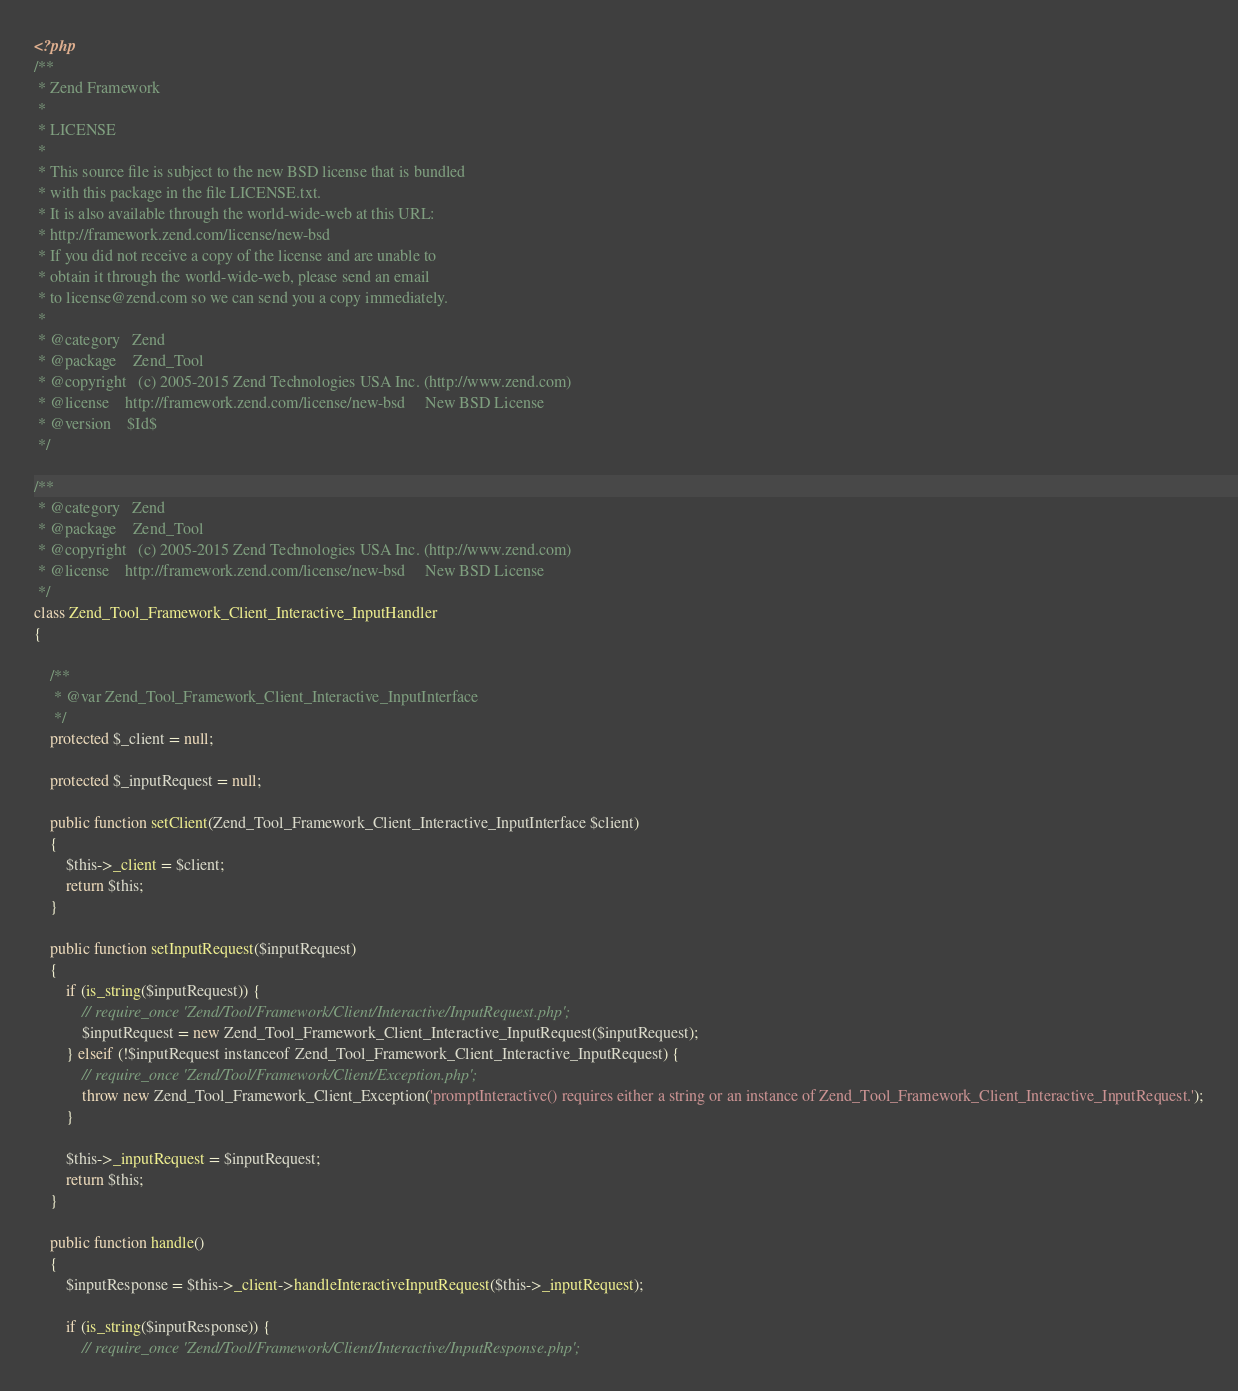Convert code to text. <code><loc_0><loc_0><loc_500><loc_500><_PHP_><?php
/**
 * Zend Framework
 *
 * LICENSE
 *
 * This source file is subject to the new BSD license that is bundled
 * with this package in the file LICENSE.txt.
 * It is also available through the world-wide-web at this URL:
 * http://framework.zend.com/license/new-bsd
 * If you did not receive a copy of the license and are unable to
 * obtain it through the world-wide-web, please send an email
 * to license@zend.com so we can send you a copy immediately.
 *
 * @category   Zend
 * @package    Zend_Tool
 * @copyright   (c) 2005-2015 Zend Technologies USA Inc. (http://www.zend.com)
 * @license    http://framework.zend.com/license/new-bsd     New BSD License
 * @version    $Id$
 */

/**
 * @category   Zend
 * @package    Zend_Tool
 * @copyright   (c) 2005-2015 Zend Technologies USA Inc. (http://www.zend.com)
 * @license    http://framework.zend.com/license/new-bsd     New BSD License
 */
class Zend_Tool_Framework_Client_Interactive_InputHandler
{

    /**
     * @var Zend_Tool_Framework_Client_Interactive_InputInterface
     */
    protected $_client = null;

    protected $_inputRequest = null;

    public function setClient(Zend_Tool_Framework_Client_Interactive_InputInterface $client)
    {
        $this->_client = $client;
        return $this;
    }

    public function setInputRequest($inputRequest)
    {
        if (is_string($inputRequest)) {
            // require_once 'Zend/Tool/Framework/Client/Interactive/InputRequest.php';
            $inputRequest = new Zend_Tool_Framework_Client_Interactive_InputRequest($inputRequest);
        } elseif (!$inputRequest instanceof Zend_Tool_Framework_Client_Interactive_InputRequest) {
            // require_once 'Zend/Tool/Framework/Client/Exception.php';
            throw new Zend_Tool_Framework_Client_Exception('promptInteractive() requires either a string or an instance of Zend_Tool_Framework_Client_Interactive_InputRequest.');
        }

        $this->_inputRequest = $inputRequest;
        return $this;
    }

    public function handle()
    {
        $inputResponse = $this->_client->handleInteractiveInputRequest($this->_inputRequest);

        if (is_string($inputResponse)) {
            // require_once 'Zend/Tool/Framework/Client/Interactive/InputResponse.php';</code> 